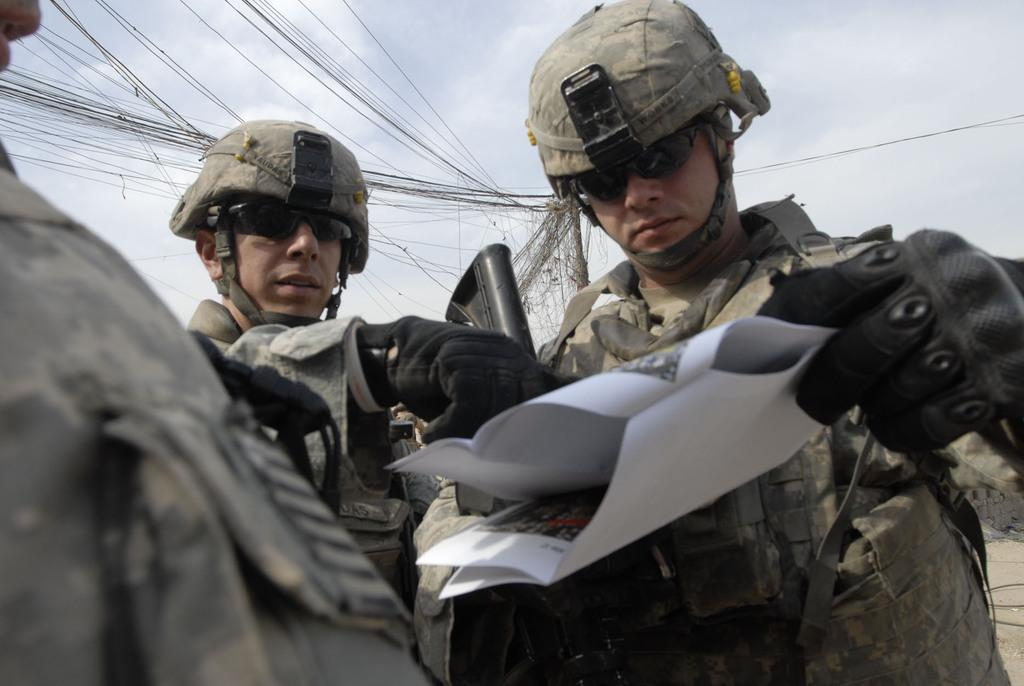What are the persons in the image holding? The persons in the image are holding guns. What else can be seen in the image besides the persons with guns? There is a paper, a pole, wires, and the sky visible in the background of the image. What is the condition of the sky in the image? The sky is visible in the background of the image, and there are clouds present. What type of ornament is hanging from the pole in the image? There is no ornament hanging from the pole in the image; only a pole and wires are present in the background. What is the need for the balloon in the image? There is no balloon present in the image, so it is not possible to determine its need or purpose. 